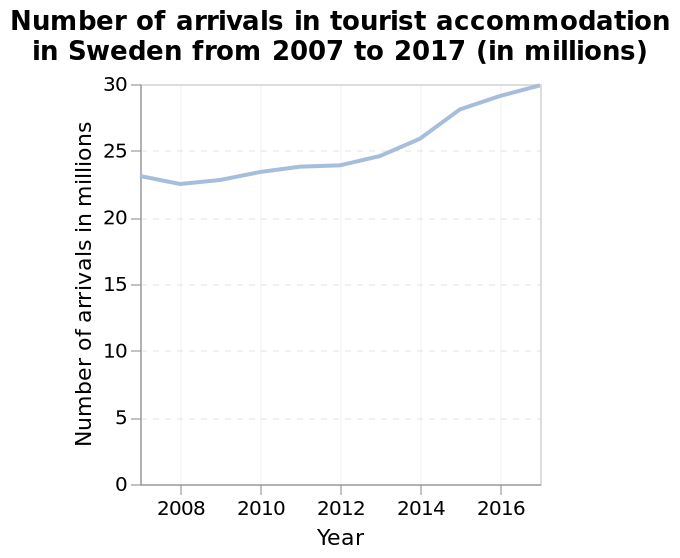<image>
How would you describe the trend in the number of visitors to Sweden since 2008?  The trend in the number of visitors to Sweden since 2008 has been steadily increasing. Is there any change in the number of visitors to Sweden since 2008?  Yes, there has been a steady increase in the number of visitors to Sweden since 2008. 